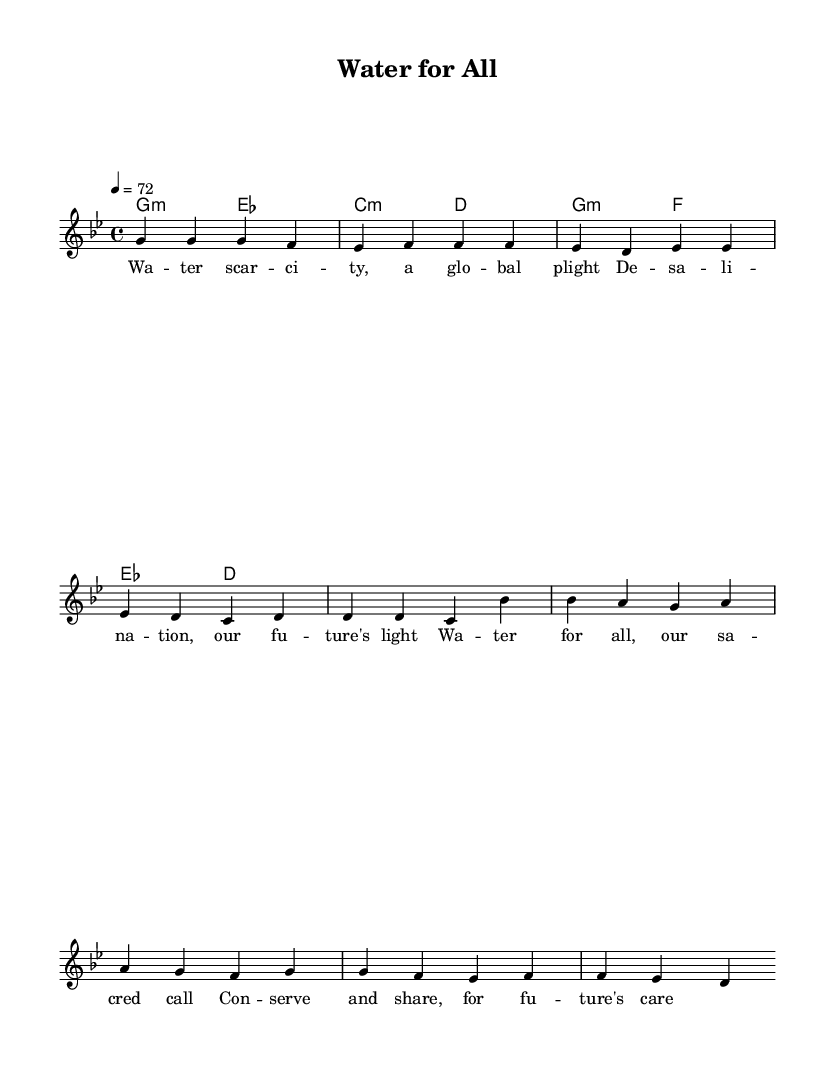What is the key signature of this music? The key signature is identified by the number of flats or sharps listed at the beginning of the staff. In this case, there are five flats indicating the key of G minor.
Answer: G minor What is the time signature of the piece? The time signature is shown at the beginning of the staff and tells us how many beats are in each measure. Here, it is 4/4, meaning there are four beats per measure.
Answer: 4/4 What is the tempo marking of this piece? The tempo marking is indicated in beats per minute (BPM) and can help determine the speed of the piece. The score indicates a tempo of 72, meaning 72 beats per minute.
Answer: 72 What are the main themes addressed in the lyrics? The lyrics reflect themes of water scarcity and the importance of conservation and sharing of resources. Key phrases include "water scarcity" and "for future's care," emphasizing global urgency and responsibility.
Answer: Water scarcity and conservation How many measures are in the verse section? To find the number of measures in the verse section, count the distinct groupings of notes and rests, where each group separated by a bar line represents a measure. The verse consists of four measures.
Answer: Four What type of chord is primarily used in the verse section? The chords listed in the harmonic section identify the quality of the chords played. The verse predominantly features minor chords, specifically G minor and C minor.
Answer: Minor chords What is the message conveyed in the chorus of the song? The chorus emphasizes a call to action regarding water resource management. It highlights the importance of sharing and conserving water. Specific phrases such as "water for all" and "sacred call" point to the urgent need for collective responsibility toward water sustainability.
Answer: Water for all 